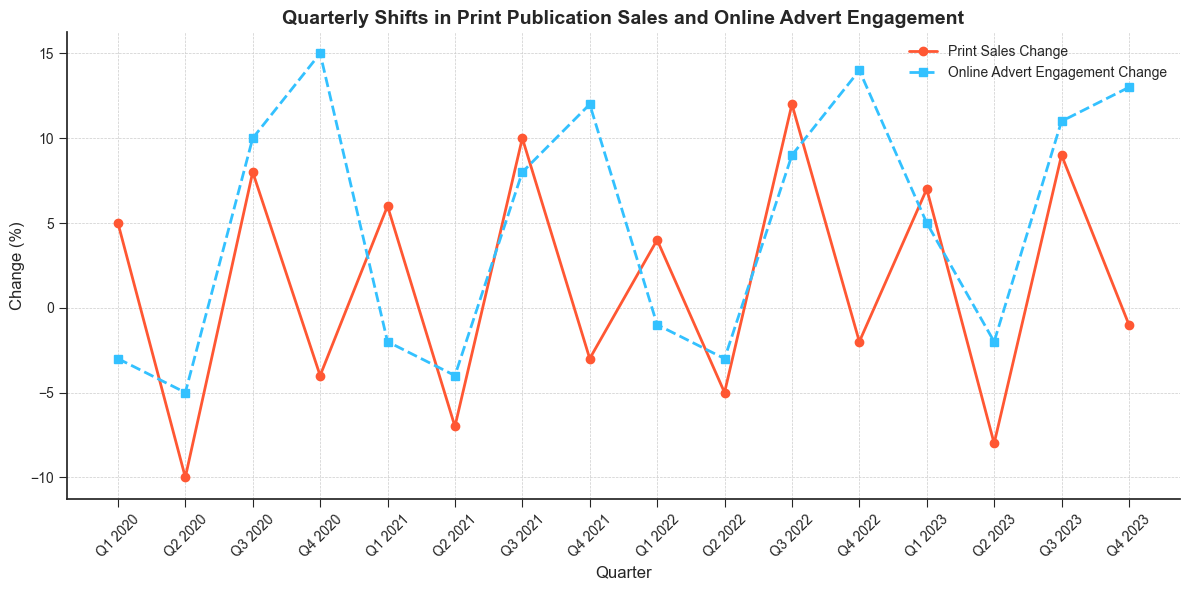How did print sales change in Q2 2020 compared to Q1 2020? In Q1 2020, print sales change was +5, while in Q2 2020, it was -10. To find the change, subtract Q2 from Q1: 5 - 10 = -15
Answer: -15 Which quarter had the highest increase in online advert engagement? By observing the line chart, Q4 2020 shows the highest value for online advert engagement change at +15
Answer: Q4 2020 How many quarters had a negative change in print sales between Q1 2020 and Q4 2023? Check the line graph to identify quarters with negative print sales change values (-): Q2 2020, Q4 2020, Q2 2021, Q4 2021, Q2 2022, Q4 2022, Q2 2023, Q4 2023. Counting these gives us 8 quarters
Answer: 8 Compare the change in print sales and online advert engagement in Q3 2020. In Q3 2020, the print sales change was +8 and online advert engagement change was +10. Compare these values to see that online advert engagement increased more significantly by 2
Answer: +2 What is the average quarterly change in print sales over the entire period? Sum the print sales change values: 5 + (-10) + 8 + (-4) + 6 + (-7) + 10 + (-3) + 4 + (-5) + 12 + (-2) + 7 + (-8) + 9 + (-1) = 21. Divide by the number of quarters (16): 21 / 16 = 1.3125
Answer: 1.3125 During which quarter did both print sales and online advert engagement decline? Find quarters where both lines are below zero. In Q2 2020, print sales change was -10 and online advert engagement change was -5. This is the quarter where both metrics decreased
Answer: Q2 2020 Which quarters exhibited simultaneous positive growth in both print sales and online advert engagement? Look for quarters where both lines are above zero: Q3 2020 (+8, +10), Q3 2021 (+10, +8), Q3 2022 (+12, +9), Q3 2023 (+9, +11). These quarters had simultaneous positive growth
Answer: Q3 2020, Q3 2021, Q3 2022, Q3 2023 What is the overall trend in online advert engagement from Q1 2020 to Q4 2023? Observe the general direction of the line representing online advert engagement. It's evident that despite fluctuations, there is an upward trend concluding with higher values in 2023 compared to the starting point in 2020
Answer: Upward trend How did print sales and online advert engagement change between Q4 2021 and Q1 2022? In Q4 2021, print sales change was -3 and online advert engagement change was +12. In Q1 2022, print sales change was +4 and online advert engagement change was -1. Calculate the differences: (+4) - (-3) = +7 for print sales, (-1) - (+12) = -13 for online adverts
Answer: +7, -13 